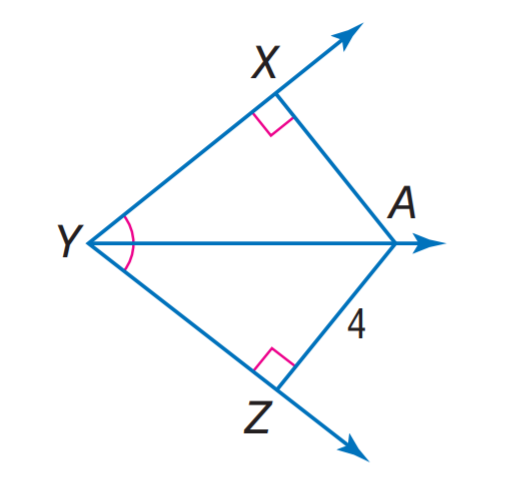Answer the mathemtical geometry problem and directly provide the correct option letter.
Question: Find X A.
Choices: A: 2 B: 4 C: 8 D: 16 B 